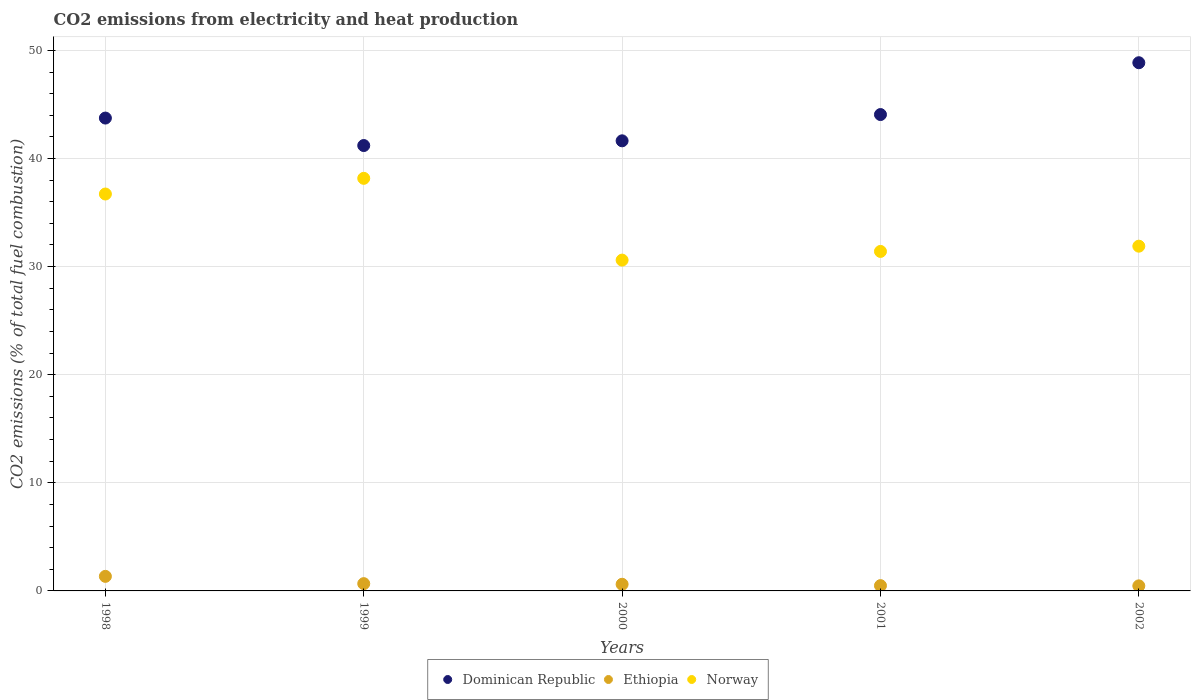How many different coloured dotlines are there?
Your answer should be compact. 3. Is the number of dotlines equal to the number of legend labels?
Your answer should be very brief. Yes. What is the amount of CO2 emitted in Ethiopia in 2002?
Your answer should be compact. 0.47. Across all years, what is the maximum amount of CO2 emitted in Norway?
Provide a short and direct response. 38.17. Across all years, what is the minimum amount of CO2 emitted in Ethiopia?
Provide a succinct answer. 0.47. In which year was the amount of CO2 emitted in Norway minimum?
Provide a succinct answer. 2000. What is the total amount of CO2 emitted in Norway in the graph?
Make the answer very short. 168.78. What is the difference between the amount of CO2 emitted in Dominican Republic in 1998 and that in 2002?
Your answer should be very brief. -5.12. What is the difference between the amount of CO2 emitted in Norway in 2002 and the amount of CO2 emitted in Ethiopia in 2000?
Provide a short and direct response. 31.27. What is the average amount of CO2 emitted in Ethiopia per year?
Provide a succinct answer. 0.72. In the year 2002, what is the difference between the amount of CO2 emitted in Dominican Republic and amount of CO2 emitted in Ethiopia?
Offer a terse response. 48.39. What is the ratio of the amount of CO2 emitted in Norway in 1998 to that in 2001?
Offer a terse response. 1.17. What is the difference between the highest and the second highest amount of CO2 emitted in Ethiopia?
Your answer should be compact. 0.67. What is the difference between the highest and the lowest amount of CO2 emitted in Ethiopia?
Offer a very short reply. 0.88. Is the sum of the amount of CO2 emitted in Norway in 2001 and 2002 greater than the maximum amount of CO2 emitted in Dominican Republic across all years?
Give a very brief answer. Yes. Does the amount of CO2 emitted in Ethiopia monotonically increase over the years?
Ensure brevity in your answer.  No. Is the amount of CO2 emitted in Ethiopia strictly less than the amount of CO2 emitted in Norway over the years?
Offer a very short reply. Yes. How many dotlines are there?
Offer a very short reply. 3. Does the graph contain any zero values?
Offer a terse response. No. What is the title of the graph?
Offer a terse response. CO2 emissions from electricity and heat production. Does "Greenland" appear as one of the legend labels in the graph?
Your answer should be very brief. No. What is the label or title of the Y-axis?
Your response must be concise. CO2 emissions (% of total fuel combustion). What is the CO2 emissions (% of total fuel combustion) of Dominican Republic in 1998?
Your response must be concise. 43.74. What is the CO2 emissions (% of total fuel combustion) in Ethiopia in 1998?
Provide a succinct answer. 1.35. What is the CO2 emissions (% of total fuel combustion) of Norway in 1998?
Ensure brevity in your answer.  36.72. What is the CO2 emissions (% of total fuel combustion) of Dominican Republic in 1999?
Offer a terse response. 41.2. What is the CO2 emissions (% of total fuel combustion) in Ethiopia in 1999?
Provide a succinct answer. 0.67. What is the CO2 emissions (% of total fuel combustion) in Norway in 1999?
Ensure brevity in your answer.  38.17. What is the CO2 emissions (% of total fuel combustion) of Dominican Republic in 2000?
Keep it short and to the point. 41.64. What is the CO2 emissions (% of total fuel combustion) of Ethiopia in 2000?
Your answer should be very brief. 0.62. What is the CO2 emissions (% of total fuel combustion) in Norway in 2000?
Your response must be concise. 30.6. What is the CO2 emissions (% of total fuel combustion) in Dominican Republic in 2001?
Provide a short and direct response. 44.07. What is the CO2 emissions (% of total fuel combustion) in Ethiopia in 2001?
Ensure brevity in your answer.  0.49. What is the CO2 emissions (% of total fuel combustion) of Norway in 2001?
Your answer should be compact. 31.4. What is the CO2 emissions (% of total fuel combustion) in Dominican Republic in 2002?
Keep it short and to the point. 48.86. What is the CO2 emissions (% of total fuel combustion) of Ethiopia in 2002?
Provide a short and direct response. 0.47. What is the CO2 emissions (% of total fuel combustion) of Norway in 2002?
Make the answer very short. 31.89. Across all years, what is the maximum CO2 emissions (% of total fuel combustion) of Dominican Republic?
Provide a succinct answer. 48.86. Across all years, what is the maximum CO2 emissions (% of total fuel combustion) of Ethiopia?
Your response must be concise. 1.35. Across all years, what is the maximum CO2 emissions (% of total fuel combustion) of Norway?
Offer a very short reply. 38.17. Across all years, what is the minimum CO2 emissions (% of total fuel combustion) of Dominican Republic?
Offer a very short reply. 41.2. Across all years, what is the minimum CO2 emissions (% of total fuel combustion) of Ethiopia?
Keep it short and to the point. 0.47. Across all years, what is the minimum CO2 emissions (% of total fuel combustion) in Norway?
Your answer should be very brief. 30.6. What is the total CO2 emissions (% of total fuel combustion) of Dominican Republic in the graph?
Your answer should be compact. 219.5. What is the total CO2 emissions (% of total fuel combustion) in Ethiopia in the graph?
Give a very brief answer. 3.59. What is the total CO2 emissions (% of total fuel combustion) of Norway in the graph?
Provide a succinct answer. 168.78. What is the difference between the CO2 emissions (% of total fuel combustion) of Dominican Republic in 1998 and that in 1999?
Give a very brief answer. 2.54. What is the difference between the CO2 emissions (% of total fuel combustion) in Ethiopia in 1998 and that in 1999?
Provide a short and direct response. 0.67. What is the difference between the CO2 emissions (% of total fuel combustion) in Norway in 1998 and that in 1999?
Provide a short and direct response. -1.45. What is the difference between the CO2 emissions (% of total fuel combustion) of Dominican Republic in 1998 and that in 2000?
Offer a very short reply. 2.11. What is the difference between the CO2 emissions (% of total fuel combustion) in Ethiopia in 1998 and that in 2000?
Provide a short and direct response. 0.73. What is the difference between the CO2 emissions (% of total fuel combustion) in Norway in 1998 and that in 2000?
Your answer should be very brief. 6.11. What is the difference between the CO2 emissions (% of total fuel combustion) in Dominican Republic in 1998 and that in 2001?
Give a very brief answer. -0.32. What is the difference between the CO2 emissions (% of total fuel combustion) in Ethiopia in 1998 and that in 2001?
Keep it short and to the point. 0.86. What is the difference between the CO2 emissions (% of total fuel combustion) in Norway in 1998 and that in 2001?
Give a very brief answer. 5.31. What is the difference between the CO2 emissions (% of total fuel combustion) in Dominican Republic in 1998 and that in 2002?
Your answer should be compact. -5.12. What is the difference between the CO2 emissions (% of total fuel combustion) of Ethiopia in 1998 and that in 2002?
Offer a very short reply. 0.88. What is the difference between the CO2 emissions (% of total fuel combustion) of Norway in 1998 and that in 2002?
Provide a short and direct response. 4.83. What is the difference between the CO2 emissions (% of total fuel combustion) in Dominican Republic in 1999 and that in 2000?
Offer a terse response. -0.44. What is the difference between the CO2 emissions (% of total fuel combustion) in Ethiopia in 1999 and that in 2000?
Offer a very short reply. 0.06. What is the difference between the CO2 emissions (% of total fuel combustion) of Norway in 1999 and that in 2000?
Give a very brief answer. 7.56. What is the difference between the CO2 emissions (% of total fuel combustion) in Dominican Republic in 1999 and that in 2001?
Make the answer very short. -2.87. What is the difference between the CO2 emissions (% of total fuel combustion) in Ethiopia in 1999 and that in 2001?
Keep it short and to the point. 0.18. What is the difference between the CO2 emissions (% of total fuel combustion) in Norway in 1999 and that in 2001?
Your response must be concise. 6.76. What is the difference between the CO2 emissions (% of total fuel combustion) in Dominican Republic in 1999 and that in 2002?
Provide a succinct answer. -7.66. What is the difference between the CO2 emissions (% of total fuel combustion) in Ethiopia in 1999 and that in 2002?
Keep it short and to the point. 0.2. What is the difference between the CO2 emissions (% of total fuel combustion) in Norway in 1999 and that in 2002?
Keep it short and to the point. 6.28. What is the difference between the CO2 emissions (% of total fuel combustion) in Dominican Republic in 2000 and that in 2001?
Your answer should be compact. -2.43. What is the difference between the CO2 emissions (% of total fuel combustion) in Ethiopia in 2000 and that in 2001?
Provide a succinct answer. 0.13. What is the difference between the CO2 emissions (% of total fuel combustion) of Norway in 2000 and that in 2001?
Offer a terse response. -0.8. What is the difference between the CO2 emissions (% of total fuel combustion) in Dominican Republic in 2000 and that in 2002?
Keep it short and to the point. -7.22. What is the difference between the CO2 emissions (% of total fuel combustion) in Ethiopia in 2000 and that in 2002?
Your answer should be very brief. 0.15. What is the difference between the CO2 emissions (% of total fuel combustion) in Norway in 2000 and that in 2002?
Offer a terse response. -1.29. What is the difference between the CO2 emissions (% of total fuel combustion) in Dominican Republic in 2001 and that in 2002?
Make the answer very short. -4.79. What is the difference between the CO2 emissions (% of total fuel combustion) of Ethiopia in 2001 and that in 2002?
Your answer should be very brief. 0.02. What is the difference between the CO2 emissions (% of total fuel combustion) in Norway in 2001 and that in 2002?
Ensure brevity in your answer.  -0.49. What is the difference between the CO2 emissions (% of total fuel combustion) in Dominican Republic in 1998 and the CO2 emissions (% of total fuel combustion) in Ethiopia in 1999?
Keep it short and to the point. 43.07. What is the difference between the CO2 emissions (% of total fuel combustion) of Dominican Republic in 1998 and the CO2 emissions (% of total fuel combustion) of Norway in 1999?
Provide a succinct answer. 5.58. What is the difference between the CO2 emissions (% of total fuel combustion) in Ethiopia in 1998 and the CO2 emissions (% of total fuel combustion) in Norway in 1999?
Offer a terse response. -36.82. What is the difference between the CO2 emissions (% of total fuel combustion) in Dominican Republic in 1998 and the CO2 emissions (% of total fuel combustion) in Ethiopia in 2000?
Offer a terse response. 43.13. What is the difference between the CO2 emissions (% of total fuel combustion) of Dominican Republic in 1998 and the CO2 emissions (% of total fuel combustion) of Norway in 2000?
Ensure brevity in your answer.  13.14. What is the difference between the CO2 emissions (% of total fuel combustion) in Ethiopia in 1998 and the CO2 emissions (% of total fuel combustion) in Norway in 2000?
Give a very brief answer. -29.26. What is the difference between the CO2 emissions (% of total fuel combustion) in Dominican Republic in 1998 and the CO2 emissions (% of total fuel combustion) in Ethiopia in 2001?
Keep it short and to the point. 43.25. What is the difference between the CO2 emissions (% of total fuel combustion) of Dominican Republic in 1998 and the CO2 emissions (% of total fuel combustion) of Norway in 2001?
Offer a terse response. 12.34. What is the difference between the CO2 emissions (% of total fuel combustion) of Ethiopia in 1998 and the CO2 emissions (% of total fuel combustion) of Norway in 2001?
Your answer should be compact. -30.06. What is the difference between the CO2 emissions (% of total fuel combustion) of Dominican Republic in 1998 and the CO2 emissions (% of total fuel combustion) of Ethiopia in 2002?
Provide a succinct answer. 43.27. What is the difference between the CO2 emissions (% of total fuel combustion) of Dominican Republic in 1998 and the CO2 emissions (% of total fuel combustion) of Norway in 2002?
Give a very brief answer. 11.85. What is the difference between the CO2 emissions (% of total fuel combustion) of Ethiopia in 1998 and the CO2 emissions (% of total fuel combustion) of Norway in 2002?
Ensure brevity in your answer.  -30.54. What is the difference between the CO2 emissions (% of total fuel combustion) in Dominican Republic in 1999 and the CO2 emissions (% of total fuel combustion) in Ethiopia in 2000?
Provide a succinct answer. 40.58. What is the difference between the CO2 emissions (% of total fuel combustion) in Dominican Republic in 1999 and the CO2 emissions (% of total fuel combustion) in Norway in 2000?
Keep it short and to the point. 10.6. What is the difference between the CO2 emissions (% of total fuel combustion) of Ethiopia in 1999 and the CO2 emissions (% of total fuel combustion) of Norway in 2000?
Provide a short and direct response. -29.93. What is the difference between the CO2 emissions (% of total fuel combustion) of Dominican Republic in 1999 and the CO2 emissions (% of total fuel combustion) of Ethiopia in 2001?
Give a very brief answer. 40.71. What is the difference between the CO2 emissions (% of total fuel combustion) in Dominican Republic in 1999 and the CO2 emissions (% of total fuel combustion) in Norway in 2001?
Make the answer very short. 9.8. What is the difference between the CO2 emissions (% of total fuel combustion) of Ethiopia in 1999 and the CO2 emissions (% of total fuel combustion) of Norway in 2001?
Your answer should be compact. -30.73. What is the difference between the CO2 emissions (% of total fuel combustion) in Dominican Republic in 1999 and the CO2 emissions (% of total fuel combustion) in Ethiopia in 2002?
Your response must be concise. 40.73. What is the difference between the CO2 emissions (% of total fuel combustion) in Dominican Republic in 1999 and the CO2 emissions (% of total fuel combustion) in Norway in 2002?
Make the answer very short. 9.31. What is the difference between the CO2 emissions (% of total fuel combustion) of Ethiopia in 1999 and the CO2 emissions (% of total fuel combustion) of Norway in 2002?
Your response must be concise. -31.22. What is the difference between the CO2 emissions (% of total fuel combustion) of Dominican Republic in 2000 and the CO2 emissions (% of total fuel combustion) of Ethiopia in 2001?
Give a very brief answer. 41.15. What is the difference between the CO2 emissions (% of total fuel combustion) of Dominican Republic in 2000 and the CO2 emissions (% of total fuel combustion) of Norway in 2001?
Your answer should be compact. 10.23. What is the difference between the CO2 emissions (% of total fuel combustion) in Ethiopia in 2000 and the CO2 emissions (% of total fuel combustion) in Norway in 2001?
Your answer should be very brief. -30.79. What is the difference between the CO2 emissions (% of total fuel combustion) of Dominican Republic in 2000 and the CO2 emissions (% of total fuel combustion) of Ethiopia in 2002?
Your answer should be compact. 41.17. What is the difference between the CO2 emissions (% of total fuel combustion) of Dominican Republic in 2000 and the CO2 emissions (% of total fuel combustion) of Norway in 2002?
Ensure brevity in your answer.  9.75. What is the difference between the CO2 emissions (% of total fuel combustion) in Ethiopia in 2000 and the CO2 emissions (% of total fuel combustion) in Norway in 2002?
Offer a terse response. -31.27. What is the difference between the CO2 emissions (% of total fuel combustion) in Dominican Republic in 2001 and the CO2 emissions (% of total fuel combustion) in Ethiopia in 2002?
Keep it short and to the point. 43.6. What is the difference between the CO2 emissions (% of total fuel combustion) of Dominican Republic in 2001 and the CO2 emissions (% of total fuel combustion) of Norway in 2002?
Your answer should be very brief. 12.18. What is the difference between the CO2 emissions (% of total fuel combustion) in Ethiopia in 2001 and the CO2 emissions (% of total fuel combustion) in Norway in 2002?
Your answer should be very brief. -31.4. What is the average CO2 emissions (% of total fuel combustion) of Dominican Republic per year?
Offer a very short reply. 43.9. What is the average CO2 emissions (% of total fuel combustion) in Ethiopia per year?
Offer a terse response. 0.72. What is the average CO2 emissions (% of total fuel combustion) of Norway per year?
Ensure brevity in your answer.  33.76. In the year 1998, what is the difference between the CO2 emissions (% of total fuel combustion) of Dominican Republic and CO2 emissions (% of total fuel combustion) of Ethiopia?
Make the answer very short. 42.39. In the year 1998, what is the difference between the CO2 emissions (% of total fuel combustion) of Dominican Republic and CO2 emissions (% of total fuel combustion) of Norway?
Offer a terse response. 7.03. In the year 1998, what is the difference between the CO2 emissions (% of total fuel combustion) of Ethiopia and CO2 emissions (% of total fuel combustion) of Norway?
Provide a succinct answer. -35.37. In the year 1999, what is the difference between the CO2 emissions (% of total fuel combustion) of Dominican Republic and CO2 emissions (% of total fuel combustion) of Ethiopia?
Make the answer very short. 40.53. In the year 1999, what is the difference between the CO2 emissions (% of total fuel combustion) in Dominican Republic and CO2 emissions (% of total fuel combustion) in Norway?
Give a very brief answer. 3.03. In the year 1999, what is the difference between the CO2 emissions (% of total fuel combustion) in Ethiopia and CO2 emissions (% of total fuel combustion) in Norway?
Provide a succinct answer. -37.49. In the year 2000, what is the difference between the CO2 emissions (% of total fuel combustion) in Dominican Republic and CO2 emissions (% of total fuel combustion) in Ethiopia?
Offer a terse response. 41.02. In the year 2000, what is the difference between the CO2 emissions (% of total fuel combustion) in Dominican Republic and CO2 emissions (% of total fuel combustion) in Norway?
Make the answer very short. 11.03. In the year 2000, what is the difference between the CO2 emissions (% of total fuel combustion) in Ethiopia and CO2 emissions (% of total fuel combustion) in Norway?
Your answer should be compact. -29.99. In the year 2001, what is the difference between the CO2 emissions (% of total fuel combustion) of Dominican Republic and CO2 emissions (% of total fuel combustion) of Ethiopia?
Your answer should be very brief. 43.58. In the year 2001, what is the difference between the CO2 emissions (% of total fuel combustion) of Dominican Republic and CO2 emissions (% of total fuel combustion) of Norway?
Offer a very short reply. 12.66. In the year 2001, what is the difference between the CO2 emissions (% of total fuel combustion) of Ethiopia and CO2 emissions (% of total fuel combustion) of Norway?
Keep it short and to the point. -30.92. In the year 2002, what is the difference between the CO2 emissions (% of total fuel combustion) of Dominican Republic and CO2 emissions (% of total fuel combustion) of Ethiopia?
Provide a short and direct response. 48.39. In the year 2002, what is the difference between the CO2 emissions (% of total fuel combustion) in Dominican Republic and CO2 emissions (% of total fuel combustion) in Norway?
Your response must be concise. 16.97. In the year 2002, what is the difference between the CO2 emissions (% of total fuel combustion) in Ethiopia and CO2 emissions (% of total fuel combustion) in Norway?
Provide a succinct answer. -31.42. What is the ratio of the CO2 emissions (% of total fuel combustion) in Dominican Republic in 1998 to that in 1999?
Provide a short and direct response. 1.06. What is the ratio of the CO2 emissions (% of total fuel combustion) in Dominican Republic in 1998 to that in 2000?
Give a very brief answer. 1.05. What is the ratio of the CO2 emissions (% of total fuel combustion) of Ethiopia in 1998 to that in 2000?
Your answer should be compact. 2.19. What is the ratio of the CO2 emissions (% of total fuel combustion) of Norway in 1998 to that in 2000?
Keep it short and to the point. 1.2. What is the ratio of the CO2 emissions (% of total fuel combustion) of Dominican Republic in 1998 to that in 2001?
Give a very brief answer. 0.99. What is the ratio of the CO2 emissions (% of total fuel combustion) in Ethiopia in 1998 to that in 2001?
Provide a short and direct response. 2.75. What is the ratio of the CO2 emissions (% of total fuel combustion) in Norway in 1998 to that in 2001?
Your answer should be compact. 1.17. What is the ratio of the CO2 emissions (% of total fuel combustion) of Dominican Republic in 1998 to that in 2002?
Provide a succinct answer. 0.9. What is the ratio of the CO2 emissions (% of total fuel combustion) of Ethiopia in 1998 to that in 2002?
Your answer should be compact. 2.87. What is the ratio of the CO2 emissions (% of total fuel combustion) of Norway in 1998 to that in 2002?
Give a very brief answer. 1.15. What is the ratio of the CO2 emissions (% of total fuel combustion) in Ethiopia in 1999 to that in 2000?
Keep it short and to the point. 1.09. What is the ratio of the CO2 emissions (% of total fuel combustion) of Norway in 1999 to that in 2000?
Provide a short and direct response. 1.25. What is the ratio of the CO2 emissions (% of total fuel combustion) of Dominican Republic in 1999 to that in 2001?
Provide a succinct answer. 0.94. What is the ratio of the CO2 emissions (% of total fuel combustion) in Ethiopia in 1999 to that in 2001?
Your response must be concise. 1.38. What is the ratio of the CO2 emissions (% of total fuel combustion) in Norway in 1999 to that in 2001?
Provide a succinct answer. 1.22. What is the ratio of the CO2 emissions (% of total fuel combustion) in Dominican Republic in 1999 to that in 2002?
Your answer should be compact. 0.84. What is the ratio of the CO2 emissions (% of total fuel combustion) in Ethiopia in 1999 to that in 2002?
Give a very brief answer. 1.43. What is the ratio of the CO2 emissions (% of total fuel combustion) of Norway in 1999 to that in 2002?
Give a very brief answer. 1.2. What is the ratio of the CO2 emissions (% of total fuel combustion) in Dominican Republic in 2000 to that in 2001?
Your answer should be very brief. 0.94. What is the ratio of the CO2 emissions (% of total fuel combustion) of Ethiopia in 2000 to that in 2001?
Your answer should be compact. 1.26. What is the ratio of the CO2 emissions (% of total fuel combustion) of Norway in 2000 to that in 2001?
Give a very brief answer. 0.97. What is the ratio of the CO2 emissions (% of total fuel combustion) in Dominican Republic in 2000 to that in 2002?
Your answer should be compact. 0.85. What is the ratio of the CO2 emissions (% of total fuel combustion) of Ethiopia in 2000 to that in 2002?
Offer a very short reply. 1.31. What is the ratio of the CO2 emissions (% of total fuel combustion) of Norway in 2000 to that in 2002?
Offer a terse response. 0.96. What is the ratio of the CO2 emissions (% of total fuel combustion) of Dominican Republic in 2001 to that in 2002?
Offer a very short reply. 0.9. What is the ratio of the CO2 emissions (% of total fuel combustion) in Ethiopia in 2001 to that in 2002?
Your response must be concise. 1.04. What is the difference between the highest and the second highest CO2 emissions (% of total fuel combustion) in Dominican Republic?
Your answer should be compact. 4.79. What is the difference between the highest and the second highest CO2 emissions (% of total fuel combustion) of Ethiopia?
Provide a short and direct response. 0.67. What is the difference between the highest and the second highest CO2 emissions (% of total fuel combustion) of Norway?
Give a very brief answer. 1.45. What is the difference between the highest and the lowest CO2 emissions (% of total fuel combustion) in Dominican Republic?
Provide a succinct answer. 7.66. What is the difference between the highest and the lowest CO2 emissions (% of total fuel combustion) in Ethiopia?
Your response must be concise. 0.88. What is the difference between the highest and the lowest CO2 emissions (% of total fuel combustion) of Norway?
Your answer should be very brief. 7.56. 